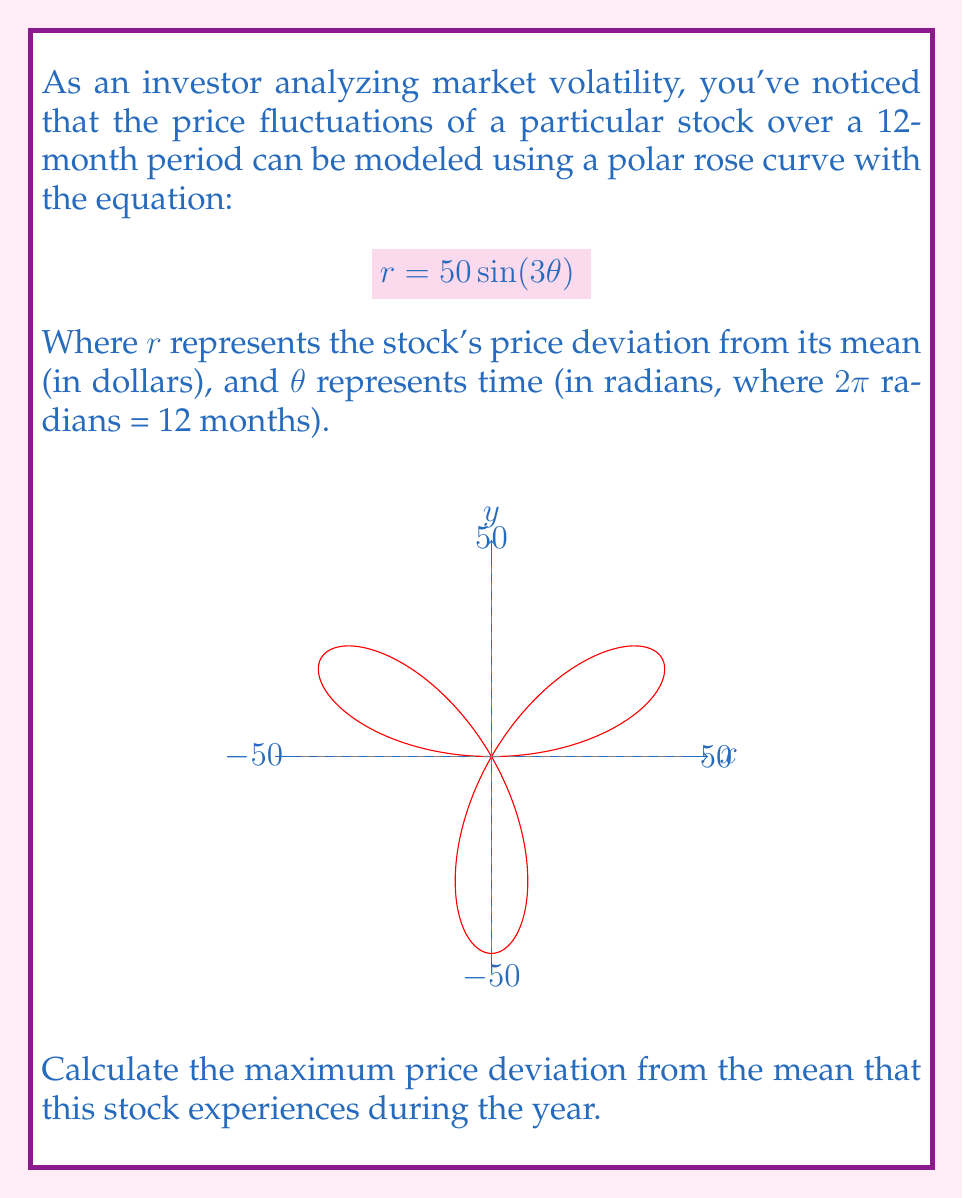Solve this math problem. Let's approach this step-by-step:

1) The equation given is $r = 50 \sin(3\theta)$. This is a polar rose curve with 3 petals, as the coefficient of $\theta$ is odd.

2) To find the maximum price deviation, we need to find the maximum value of $r$.

3) The sine function has a maximum value of 1 and a minimum value of -1.

4) Given that $r = 50 \sin(3\theta)$, the maximum value of $r$ will occur when $\sin(3\theta) = 1$, and the minimum when $\sin(3\theta) = -1$.

5) Therefore, the maximum value of $r$ is:

   $$r_{max} = 50 \cdot 1 = 50$$

6) The minimum value of $r$ is:

   $$r_{min} = 50 \cdot (-1) = -50$$

7) Both of these represent a deviation of 50 dollars from the mean price.

8) The question asks for the maximum deviation, which is 50 dollars.

This means that at certain points in the year, the stock price reaches 50 dollars above its mean price, and at other points, it reaches 50 dollars below its mean price.
Answer: $50 